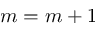Convert formula to latex. <formula><loc_0><loc_0><loc_500><loc_500>m = m + 1</formula> 